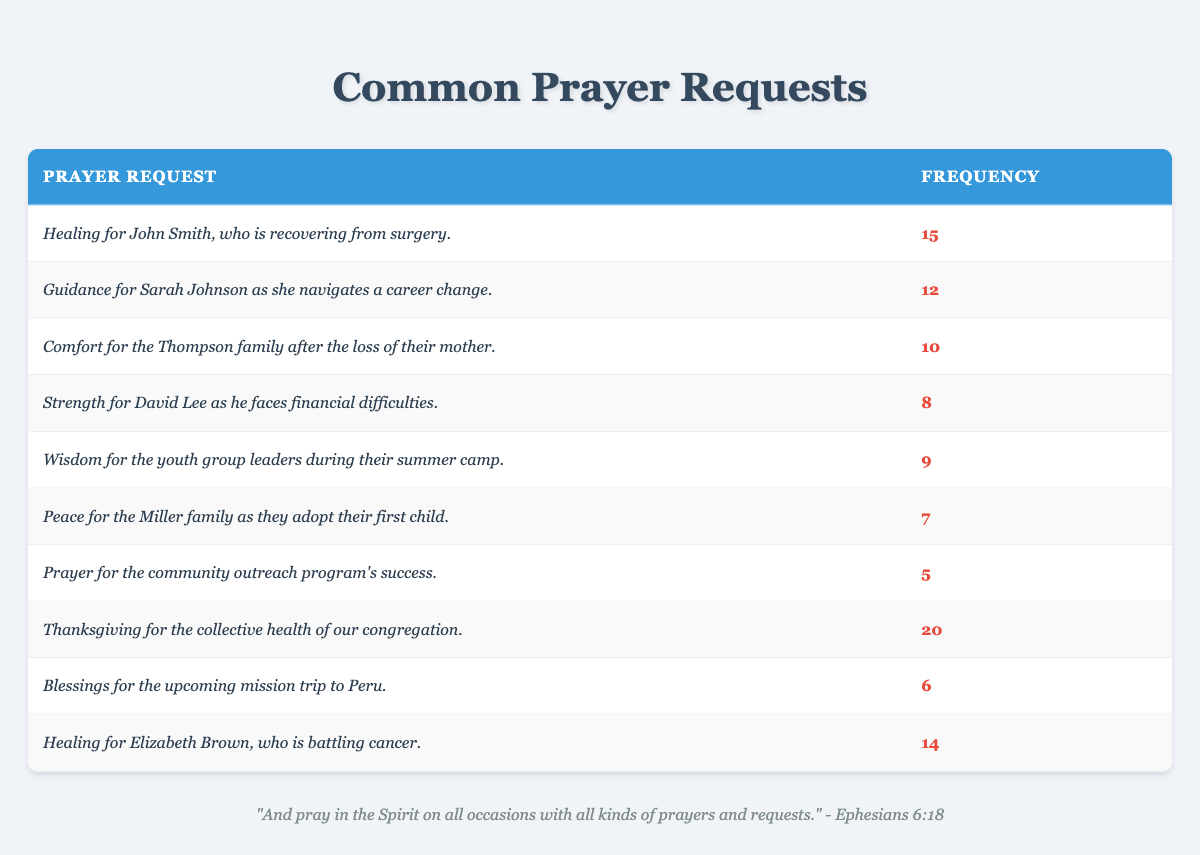What is the most frequent prayer request in the table? The prayer request with the highest frequency is for "Thanksgiving for the collective health of our congregation," which has a frequency of 20.
Answer: Thanksgiving for the collective health of our congregation How many prayer requests have a frequency greater than 10? There are four requests with frequencies greater than 10: "Thanksgiving for the collective health of our congregation" (20), "Healing for John Smith" (15), "Healing for Elizabeth Brown" (14), and "Guidance for Sarah Johnson" (12).
Answer: 4 What is the total frequency of all the prayer requests? To find the total frequency, add all the frequencies together: 15 + 12 + 10 + 8 + 9 + 7 + 5 + 20 + 6 + 14 = 96.
Answer: 96 Is there a prayer request for wisdom related to youth group leaders? Yes, the table includes a request for "Wisdom for the youth group leaders during their summer camp," with a frequency of 9.
Answer: Yes What is the difference in frequency between the request for comfort for the Thompson family and the request for peace for the Miller family? The frequency for comfort is 10 and for peace is 7. The difference is 10 - 7 = 3.
Answer: 3 What is the average frequency of all prayer requests? To find the average, sum the frequencies (96) and divide by the number of requests (10): 96/10 = 9.6.
Answer: 9.6 Which prayer request has the lowest frequency and what is that frequency? The prayer request with the lowest frequency is for "Prayer for the community outreach program's success," which has a frequency of 5.
Answer: Prayer for the community outreach program's success; frequency is 5 Are there more requests for healing than requests for guidance? Yes, there are 2 requests for healing ("Healing for John Smith" with 15 and "Healing for Elizabeth Brown" with 14) and 1 request for guidance ("Guidance for Sarah Johnson" with 12), so healing requests are more numerous.
Answer: Yes If you combine the frequencies of prayer requests related to healing, what would that total be? "Healing for John Smith" has a frequency of 15 and "Healing for Elizabeth Brown" has a frequency of 14, so 15 + 14 = 29.
Answer: 29 How many requests are there for comfort or peace? There is one request for comfort ("Comfort for the Thompson family") with a frequency of 10 and one request for peace ("Peace for the Miller family") with a frequency of 7. Therefore, the total is 1 + 1 = 2.
Answer: 2 